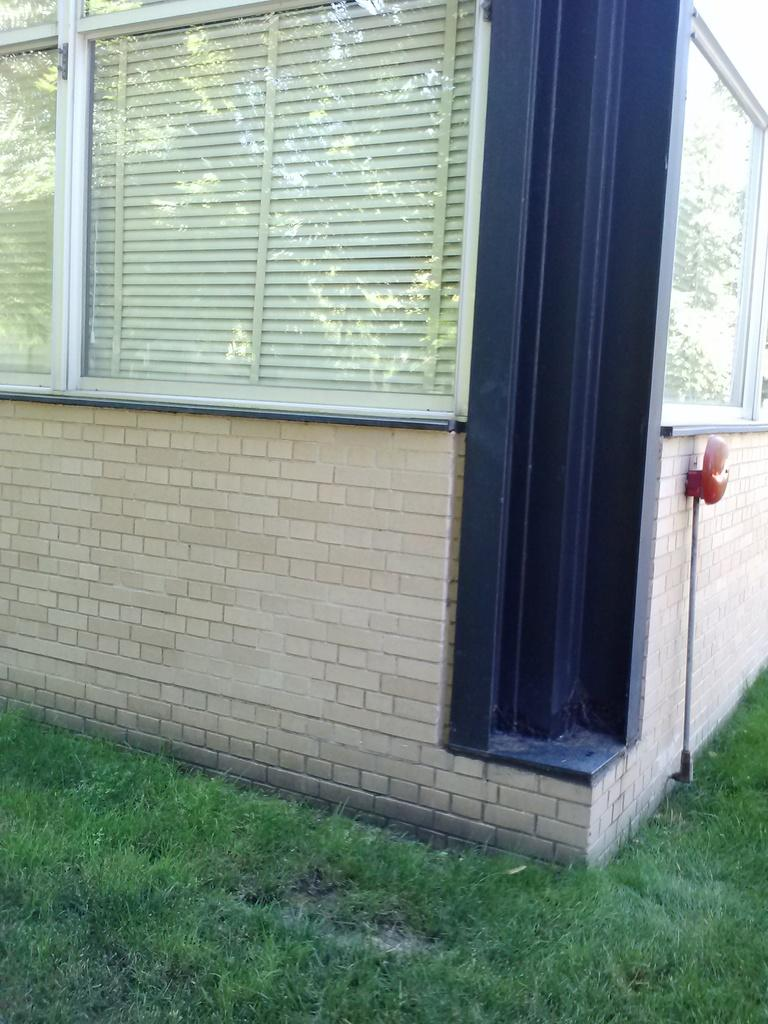What type of vegetation is present in the image? There is grass in the image. What type of structures can be seen in the image? There are walls in the image. What allows light to enter the structures in the image? There are windows in the image. Can you describe the unspecified object in the image? Unfortunately, the facts provided do not give any details about the unspecified object, so it cannot be described. Can you tell me how many people are swimming in the image? There is no indication of swimming or people in the image; it features grass, walls, windows, and an unspecified object. What type of building is depicted in the image? The facts provided do not specify that the image contains a building, only walls and windows. 